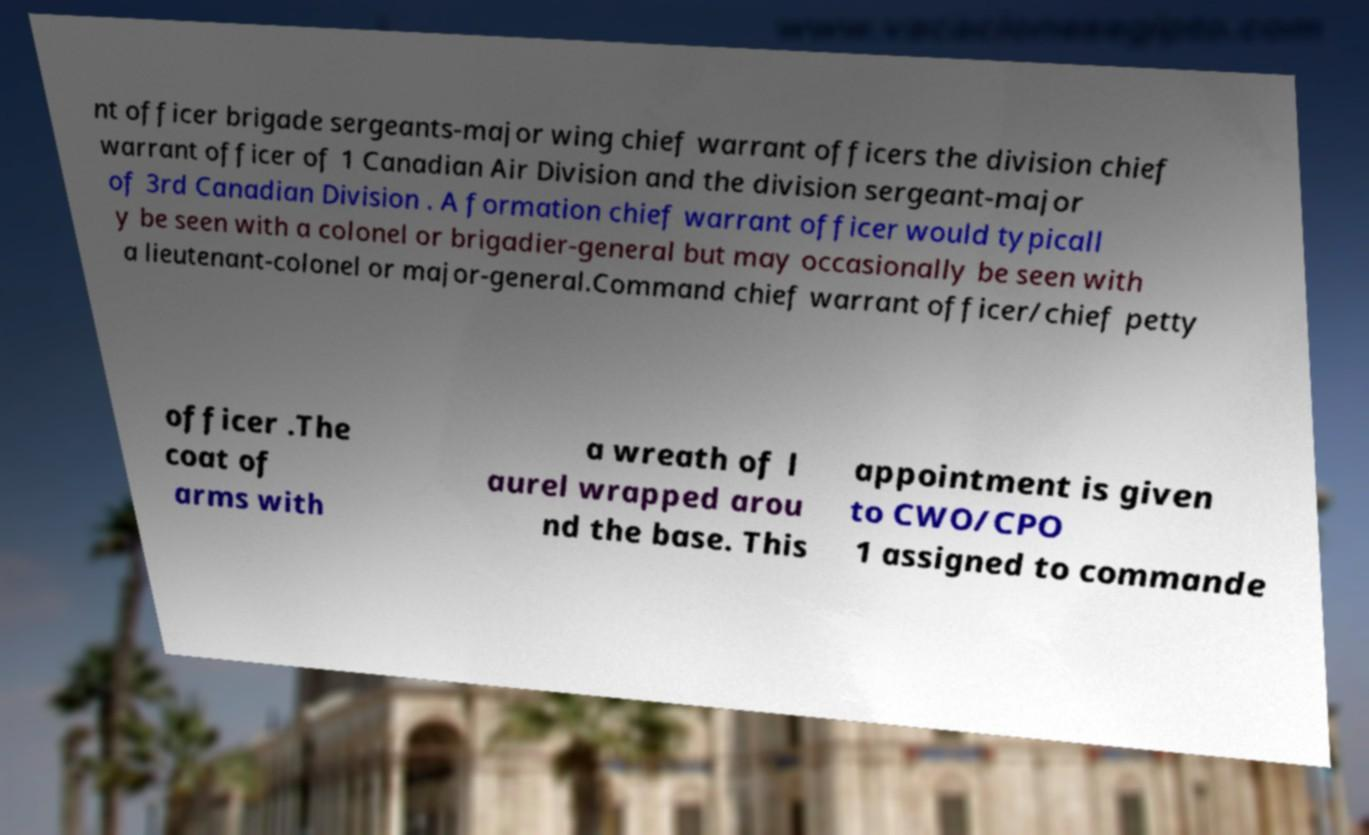Could you extract and type out the text from this image? nt officer brigade sergeants-major wing chief warrant officers the division chief warrant officer of 1 Canadian Air Division and the division sergeant-major of 3rd Canadian Division . A formation chief warrant officer would typicall y be seen with a colonel or brigadier-general but may occasionally be seen with a lieutenant-colonel or major-general.Command chief warrant officer/chief petty officer .The coat of arms with a wreath of l aurel wrapped arou nd the base. This appointment is given to CWO/CPO 1 assigned to commande 